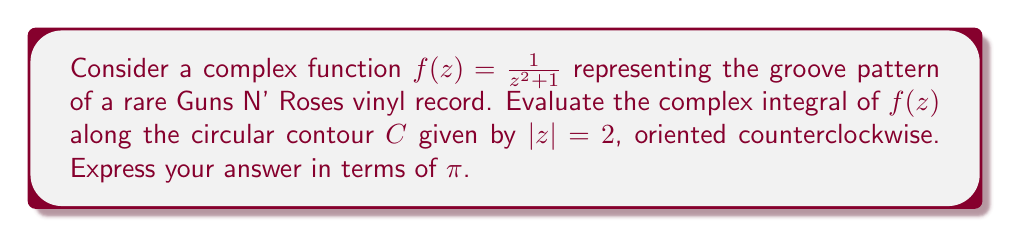Give your solution to this math problem. To evaluate this complex integral, we'll use the Residue Theorem. The steps are as follows:

1) First, we need to find the poles of $f(z)$ inside the contour $C$.
   The poles are the roots of $z^2 + 1 = 0$, which are $z = \pm i$.
   Only $z = i$ lies inside $C$ since $|i| = 1 < 2$.

2) Next, we calculate the residue of $f(z)$ at $z = i$:
   $$\text{Res}(f, i) = \lim_{z \to i} (z-i)f(z) = \lim_{z \to i} \frac{z-i}{z^2+1} = \frac{1}{2i}$$

3) The Residue Theorem states that for a function $f(z)$ that is analytic except for isolated singularities inside a simple closed contour $C$:
   $$\oint_C f(z) dz = 2\pi i \sum \text{Res}(f, a_k)$$
   where $a_k$ are the poles of $f(z)$ inside $C$.

4) Applying the Residue Theorem to our problem:
   $$\oint_C \frac{1}{z^2 + 1} dz = 2\pi i \cdot \text{Res}(f, i) = 2\pi i \cdot \frac{1}{2i} = \pi$$

Therefore, the value of the integral is $\pi$.
Answer: $\pi$ 